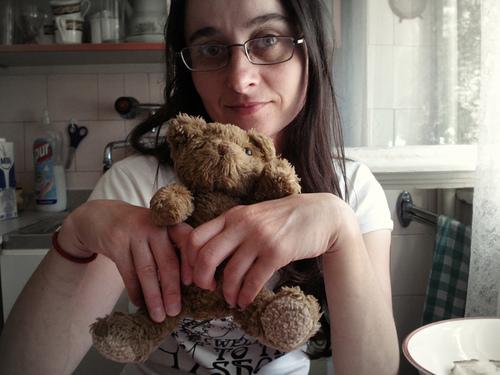What room is the human sitting in?
Write a very short answer. Kitchen. What is the woman wearing on her face?
Short answer required. Glasses. What item is the woman holding in her hands?
Answer briefly. Teddy bear. 